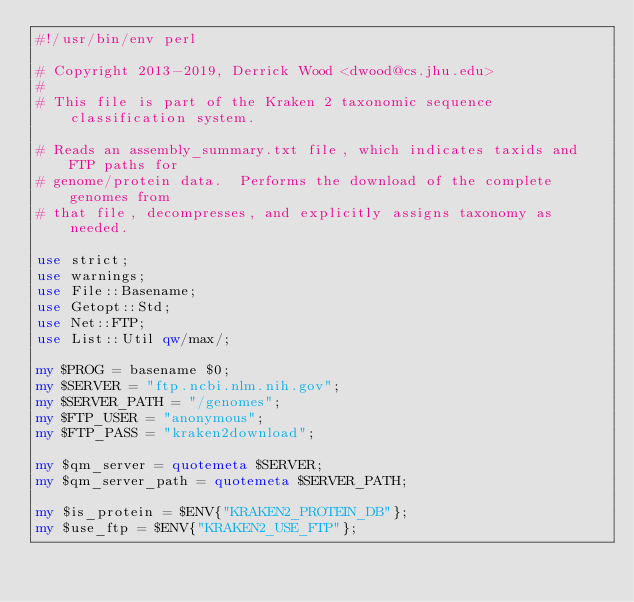<code> <loc_0><loc_0><loc_500><loc_500><_Perl_>#!/usr/bin/env perl

# Copyright 2013-2019, Derrick Wood <dwood@cs.jhu.edu>
#
# This file is part of the Kraken 2 taxonomic sequence classification system.

# Reads an assembly_summary.txt file, which indicates taxids and FTP paths for
# genome/protein data.  Performs the download of the complete genomes from
# that file, decompresses, and explicitly assigns taxonomy as needed.

use strict;
use warnings;
use File::Basename;
use Getopt::Std;
use Net::FTP;
use List::Util qw/max/;

my $PROG = basename $0;
my $SERVER = "ftp.ncbi.nlm.nih.gov";
my $SERVER_PATH = "/genomes";
my $FTP_USER = "anonymous";
my $FTP_PASS = "kraken2download";

my $qm_server = quotemeta $SERVER;
my $qm_server_path = quotemeta $SERVER_PATH;

my $is_protein = $ENV{"KRAKEN2_PROTEIN_DB"};
my $use_ftp = $ENV{"KRAKEN2_USE_FTP"};
</code> 